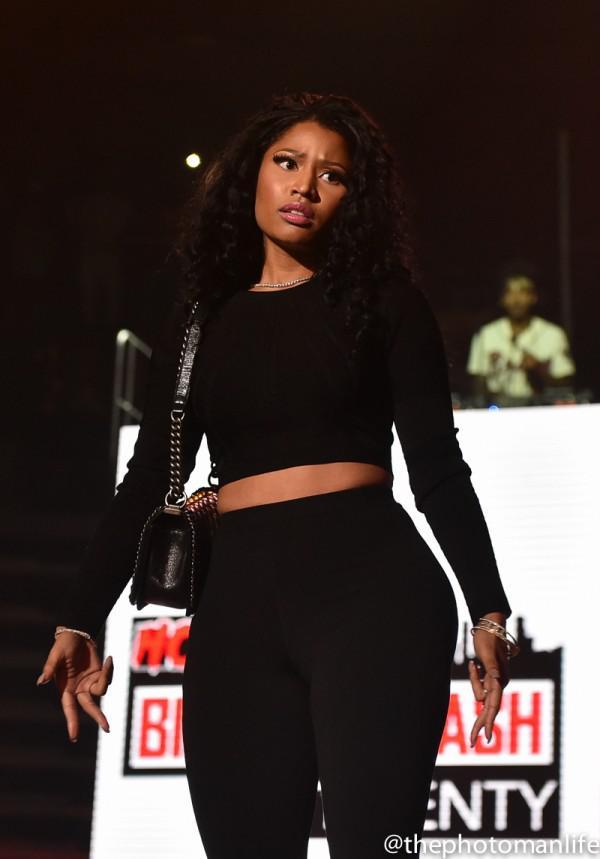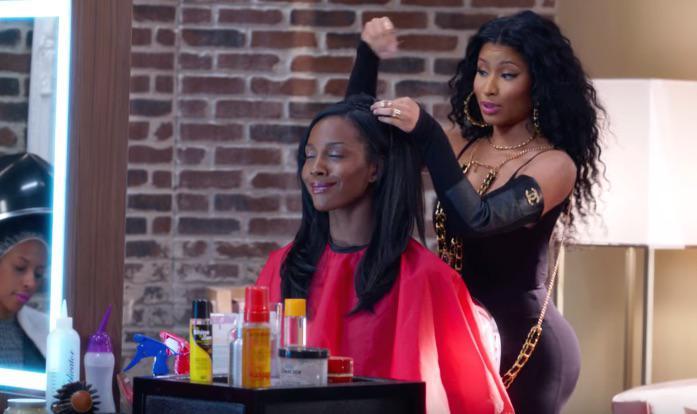The first image is the image on the left, the second image is the image on the right. For the images displayed, is the sentence "She is wearing the same necklace in every single image." factually correct? Answer yes or no. No. The first image is the image on the left, the second image is the image on the right. Analyze the images presented: Is the assertion "One of the images has two different women." valid? Answer yes or no. Yes. 